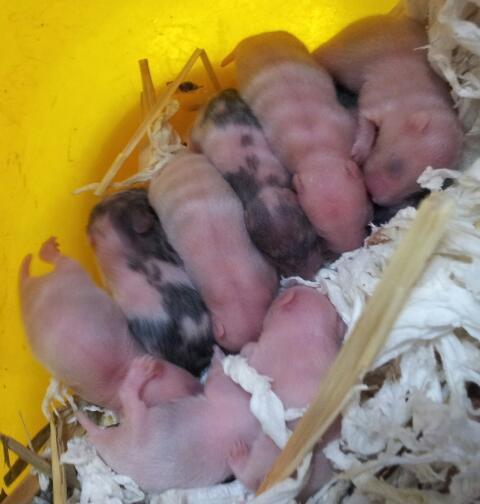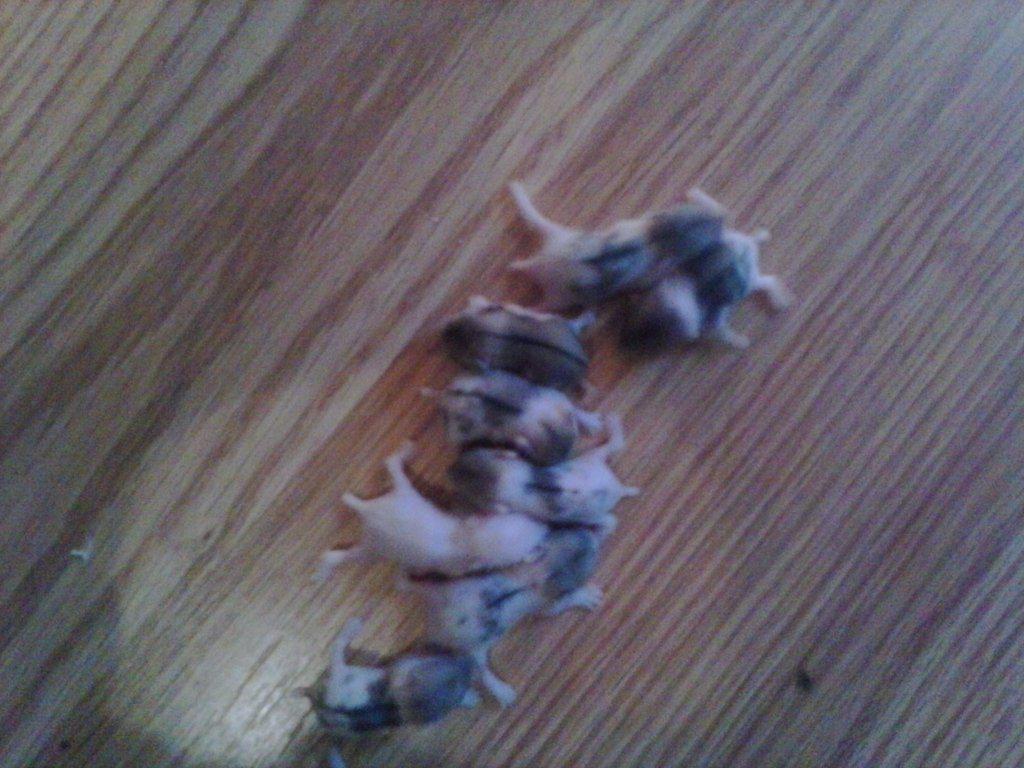The first image is the image on the left, the second image is the image on the right. Assess this claim about the two images: "The left image contains only non-newborn mouse-like pets, and the right image shows all mouse-like pets on shredded bedding.". Correct or not? Answer yes or no. No. 